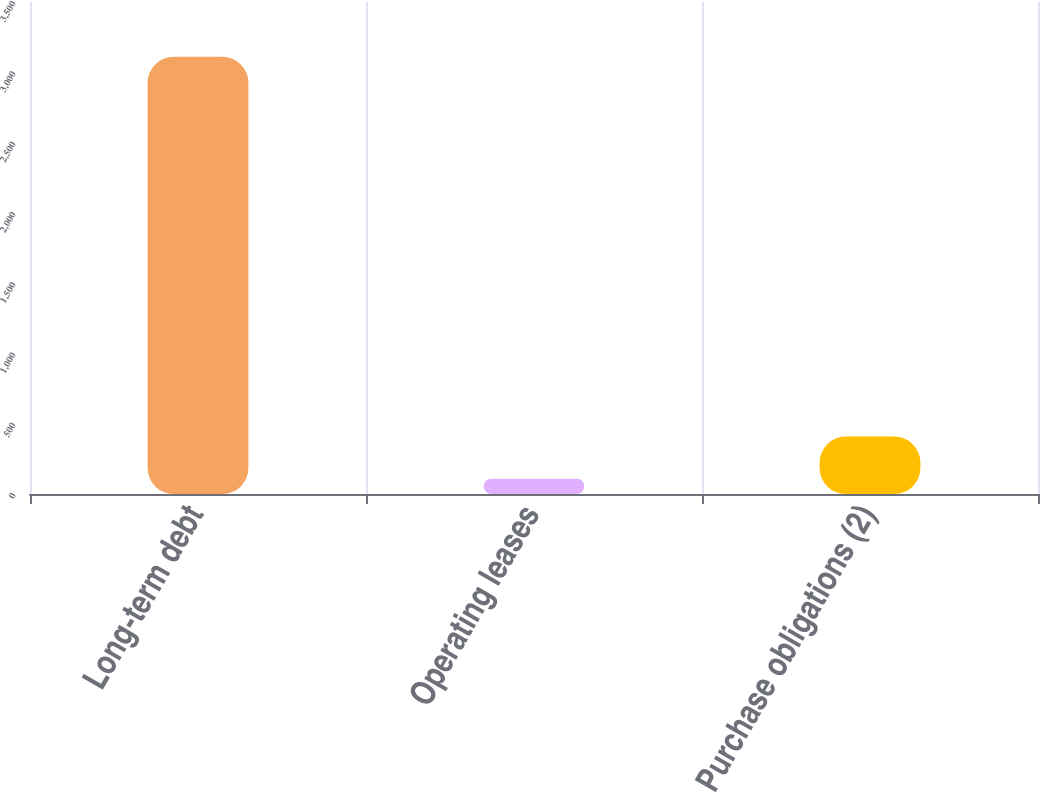Convert chart. <chart><loc_0><loc_0><loc_500><loc_500><bar_chart><fcel>Long-term debt<fcel>Operating leases<fcel>Purchase obligations (2)<nl><fcel>3110<fcel>108<fcel>408.2<nl></chart> 